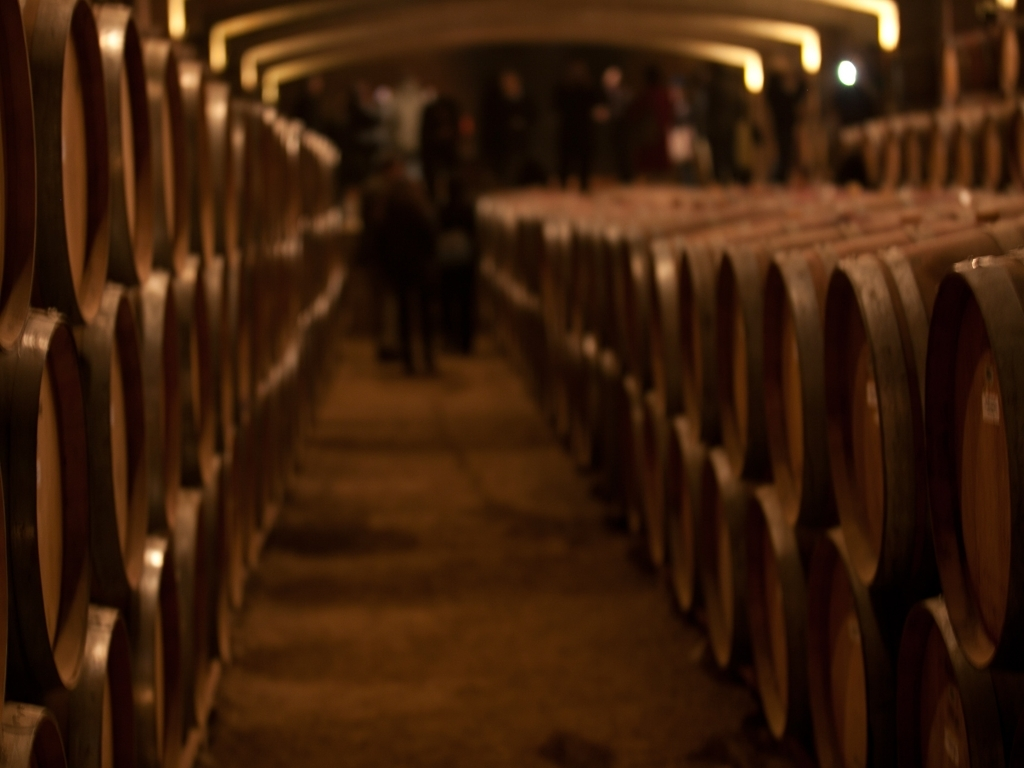Are there any specific elements in this image that indicate where it might be located? While the image does not provide explicit geographic markers, the extensive use of wooden barrels for aging, combined with the architectural style of the cellar, may suggest a location within a region known for wine or spirit production, such as parts of Europe, North America, or specific regions in other continents known for such industries. 